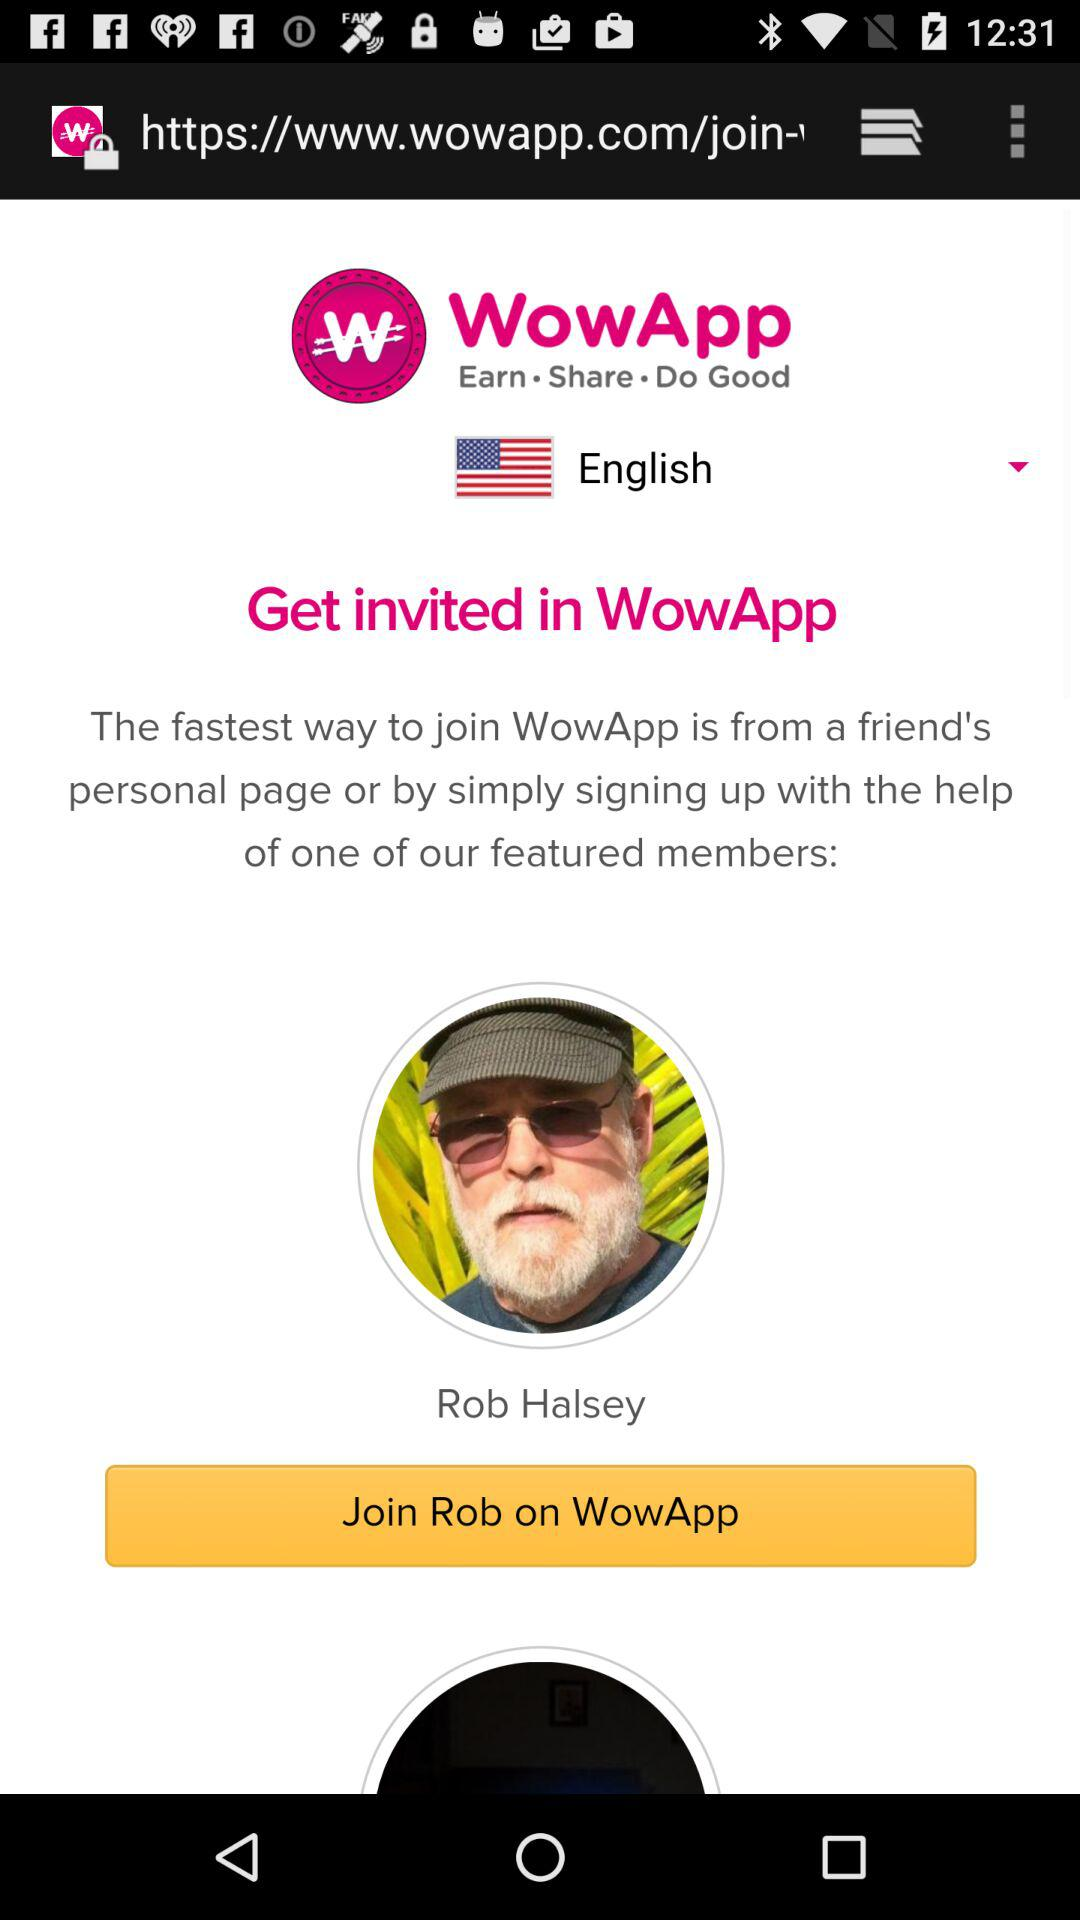Which other languages are available in the drop-down menu?
When the provided information is insufficient, respond with <no answer>. <no answer> 